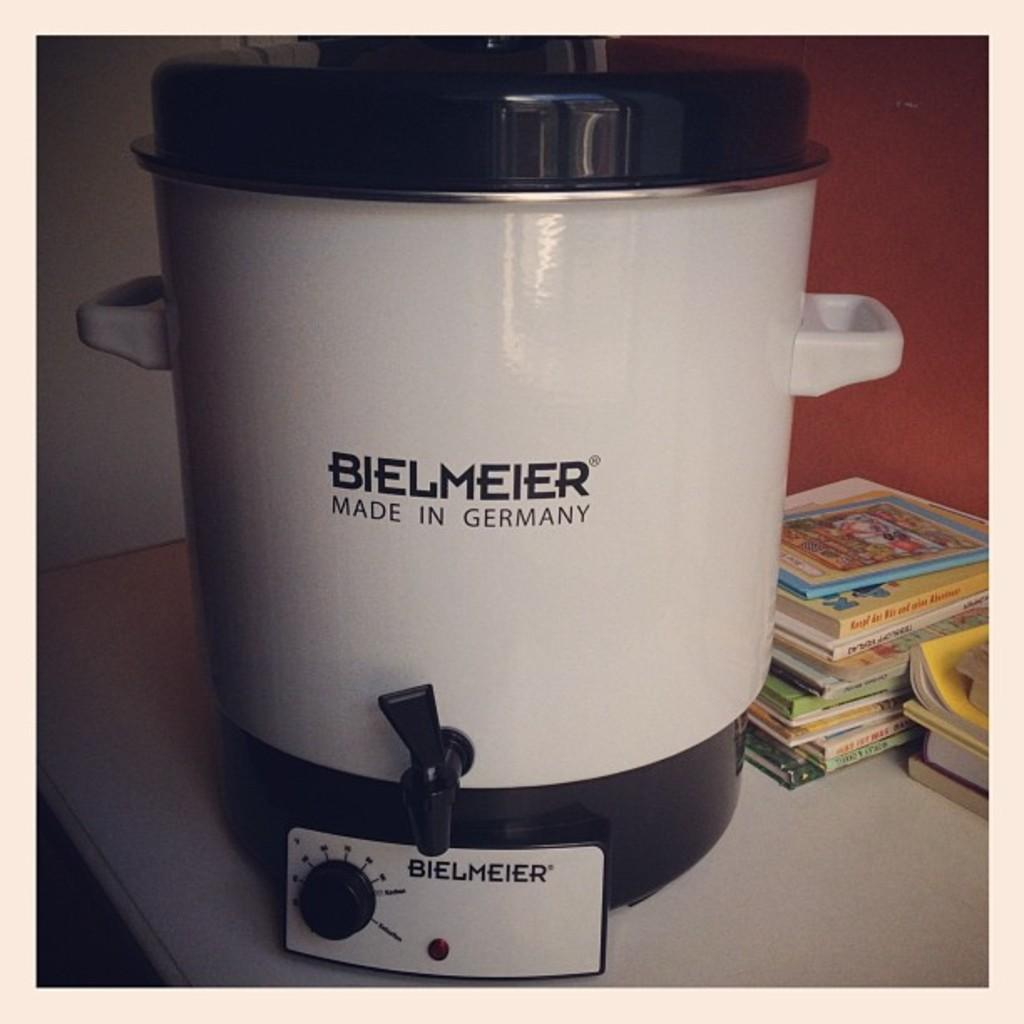<image>
Give a short and clear explanation of the subsequent image. A Bielmeier product sits on a counter along with some books. 